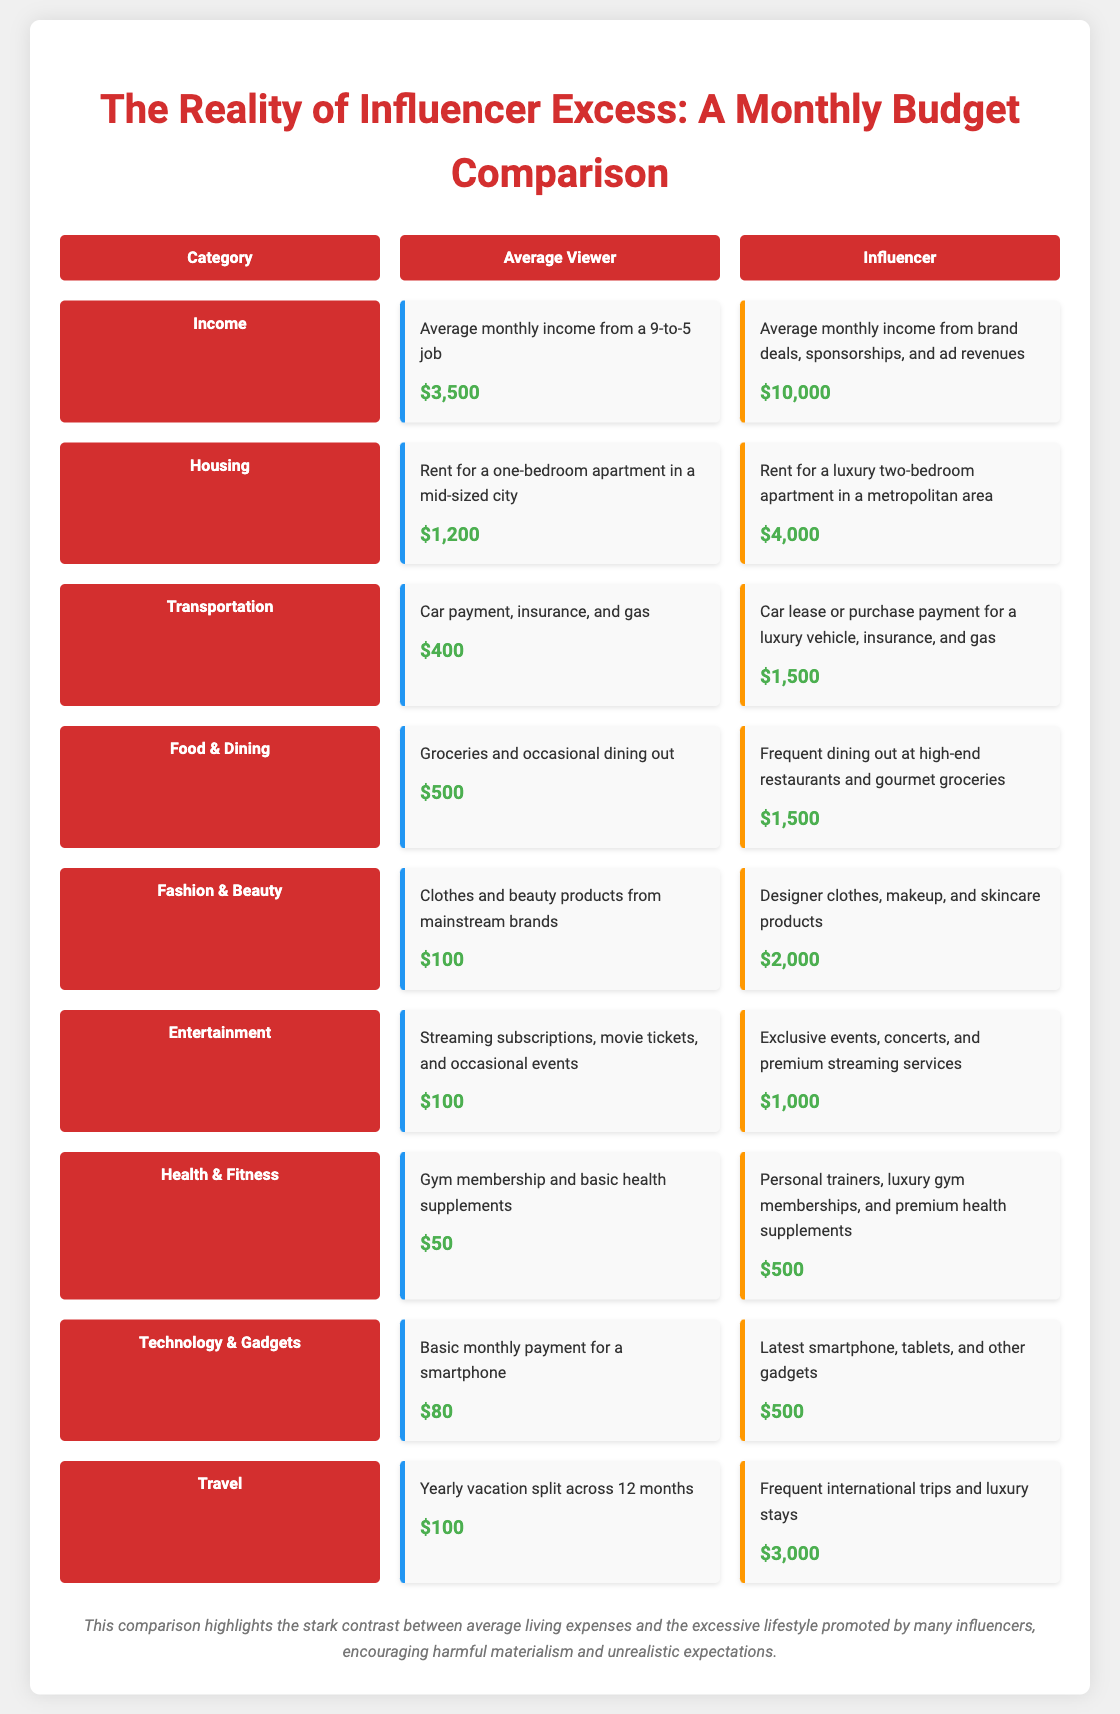what is the average monthly income for the average viewer? The average monthly income for the average viewer is detailed in the Income section of the document.
Answer: $3,500 what is the average monthly income for influencers? The average income for influencers is presented in the Income category.
Answer: $10,000 how much does the average viewer spend on housing? The housing expense for the average viewer is specified in the Housing category.
Answer: $1,200 what is the transportation expense for influencers? The transportation costs for influencers are listed in the Transportation section.
Answer: $1,500 what is the difference in food and dining expenses between the average viewer and influencers? The document provides both food and dining expenses for viewers and influencers to compare.
Answer: $1,000 which category shows the most significant spending difference? This question requires analyzing the spending differences across all categories.
Answer: Travel what is the total food and dining expense for the average viewer and influencer combined? This question combines the food and dining expenses for both groups found in the Food & Dining section of the document.
Answer: $2,000 how much do influencers spend on technology and gadgets? This is specified in the Technology & Gadgets category of the comparison.
Answer: $500 what is the total monthly budget for the average viewer? This requires adding up all the expenses listed for the average viewer across different categories.
Answer: $2,880 